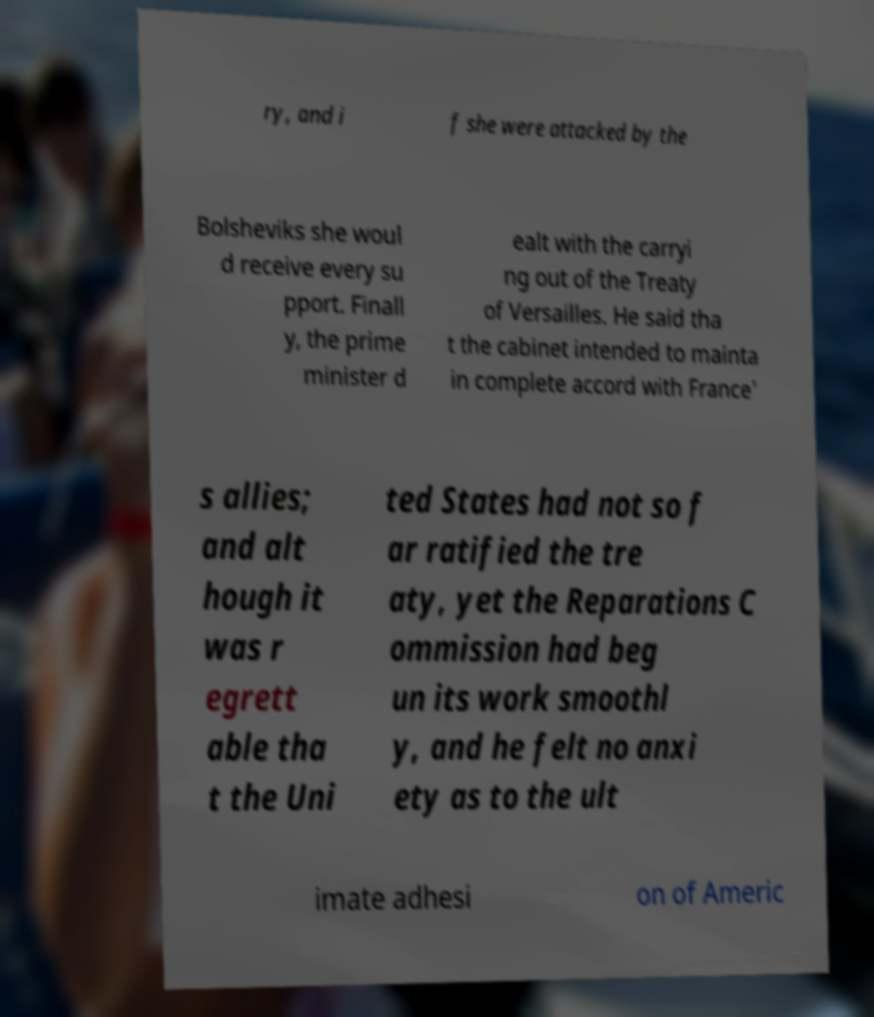I need the written content from this picture converted into text. Can you do that? ry, and i f she were attacked by the Bolsheviks she woul d receive every su pport. Finall y, the prime minister d ealt with the carryi ng out of the Treaty of Versailles. He said tha t the cabinet intended to mainta in complete accord with France' s allies; and alt hough it was r egrett able tha t the Uni ted States had not so f ar ratified the tre aty, yet the Reparations C ommission had beg un its work smoothl y, and he felt no anxi ety as to the ult imate adhesi on of Americ 